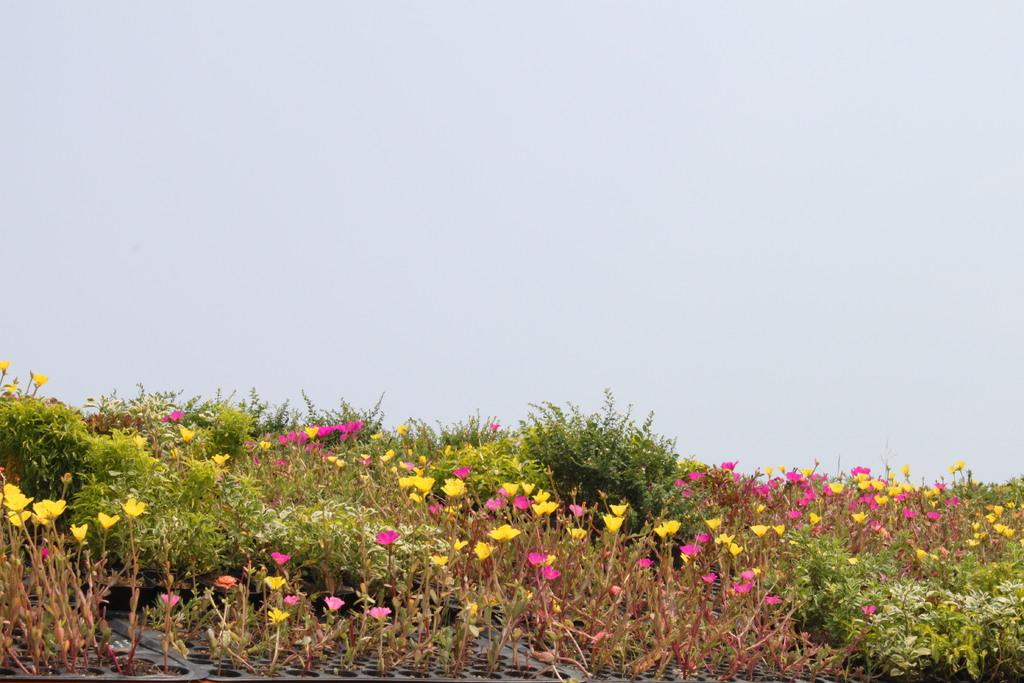What type of plants can be seen in the image? There are plants with flowers in the image. How are some of the plants arranged in the image? Some plants are placed on a tray. What is visible at the top of the image? The sky is visible at the top of the image. How many mice are running around the plants in the image? There are no mice present in the image. What type of flag is visible in the image? There is no flag present in the image. 